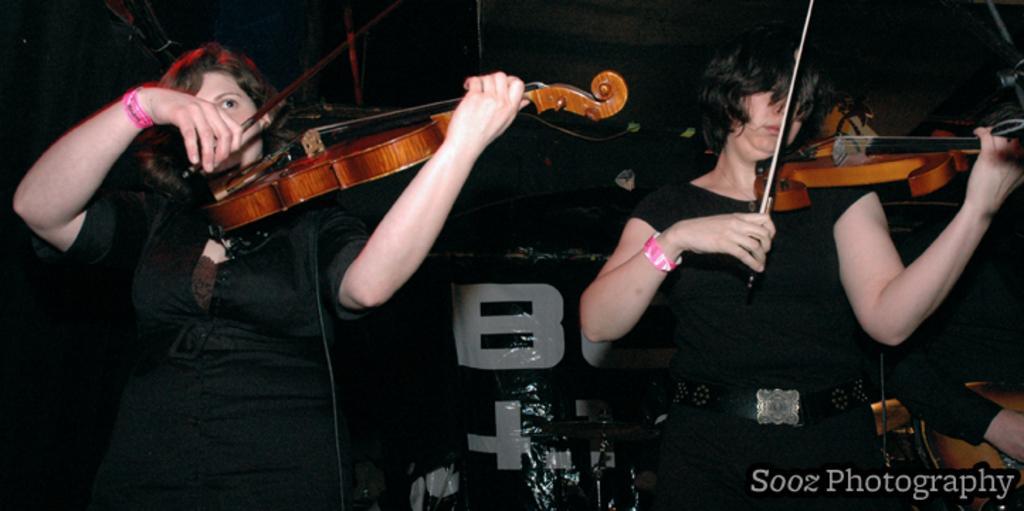Could you give a brief overview of what you see in this image? They are playing musical instruments. They are wearing very colorful black shirts. 